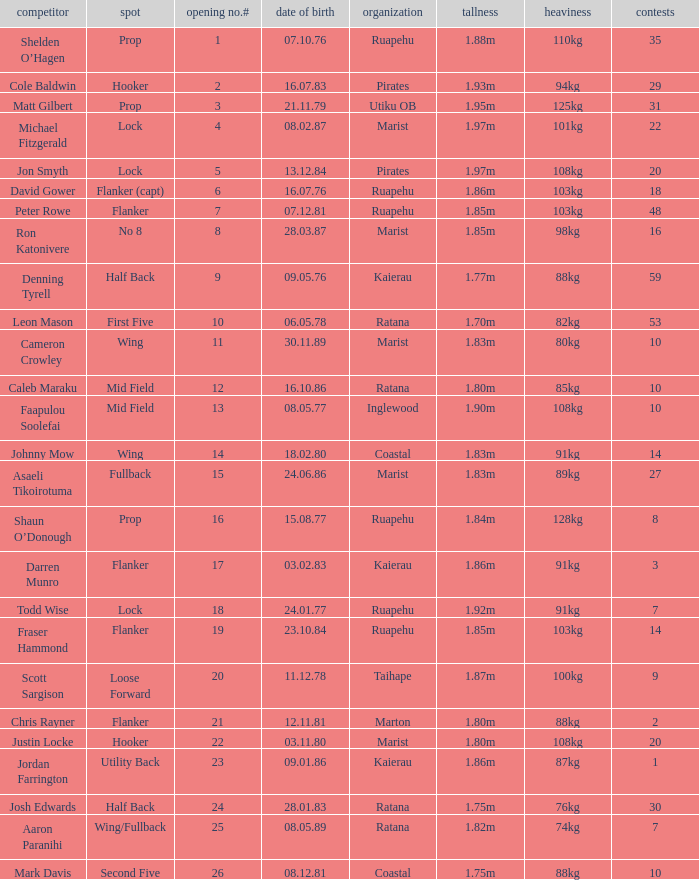How many games were played where the height of the player is 1.92m? 1.0. 